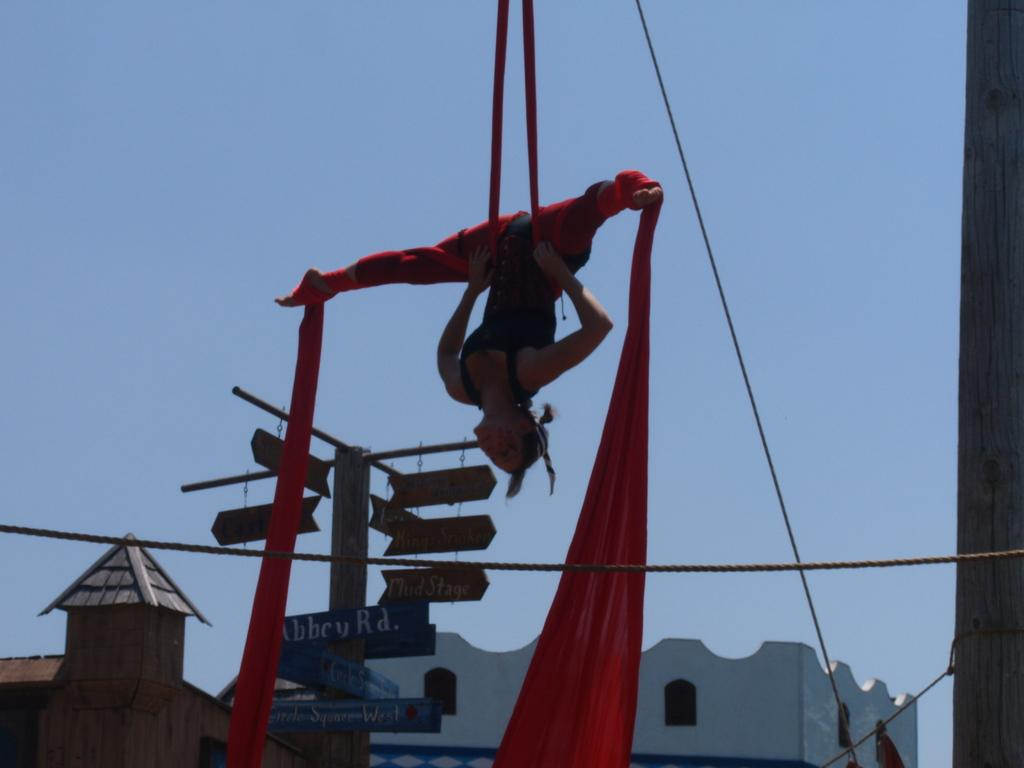Who is present in the image? There is a woman in the image. What is the woman's position in the image? The woman is tied to a clothesline in the air. What can be seen in the background of the image? There are buildings, boards on a pole, windows, and the sky visible in the background. What objects are present in the image that are related to the woman's position? There is a rope and a pole on the right side of the image. How many mittens can be seen on the woman's hands in the image? There are no mittens visible on the woman's hands in the image. What type of houses are depicted in the background? There are no houses depicted in the image. 